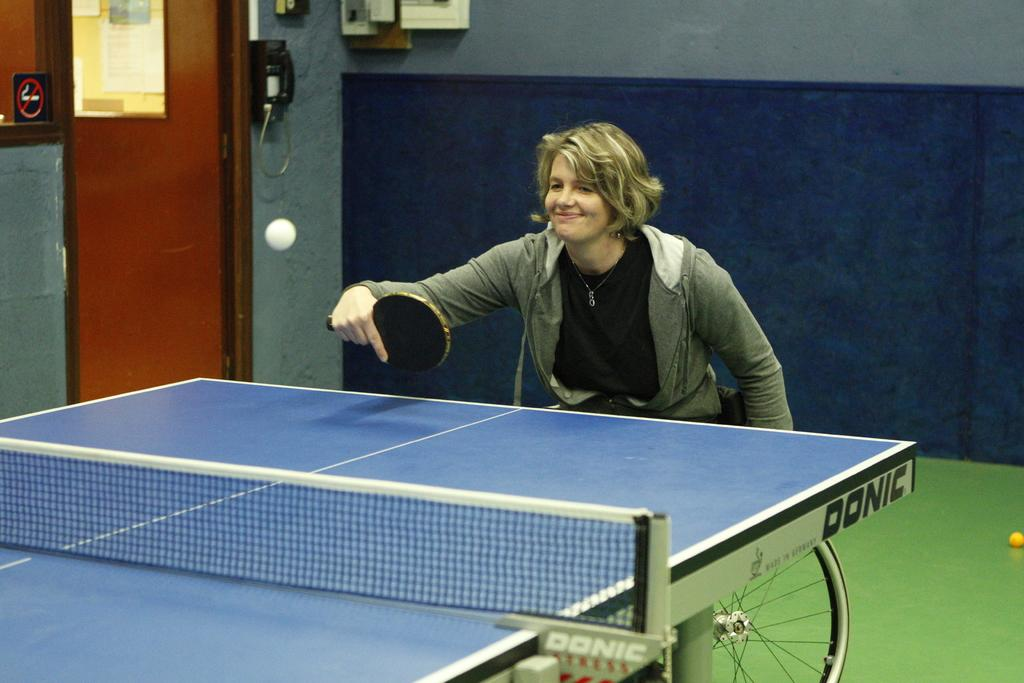Who is the main subject in the image? There is a woman in the image. What is the woman doing in the image? The woman is playing table tennis. What object is the woman holding in her hand? The woman is holding a bat in her hand. What is the woman's facial expression in the image? The woman is smiling. What can be seen on the table in the image? There is a table with a net in the image. What architectural features are present in the image? There is a door and a wall in the image. What type of weather can be seen through the door in the image? There is no weather visible through the door in the image, as it is an architectural feature and not a window. 